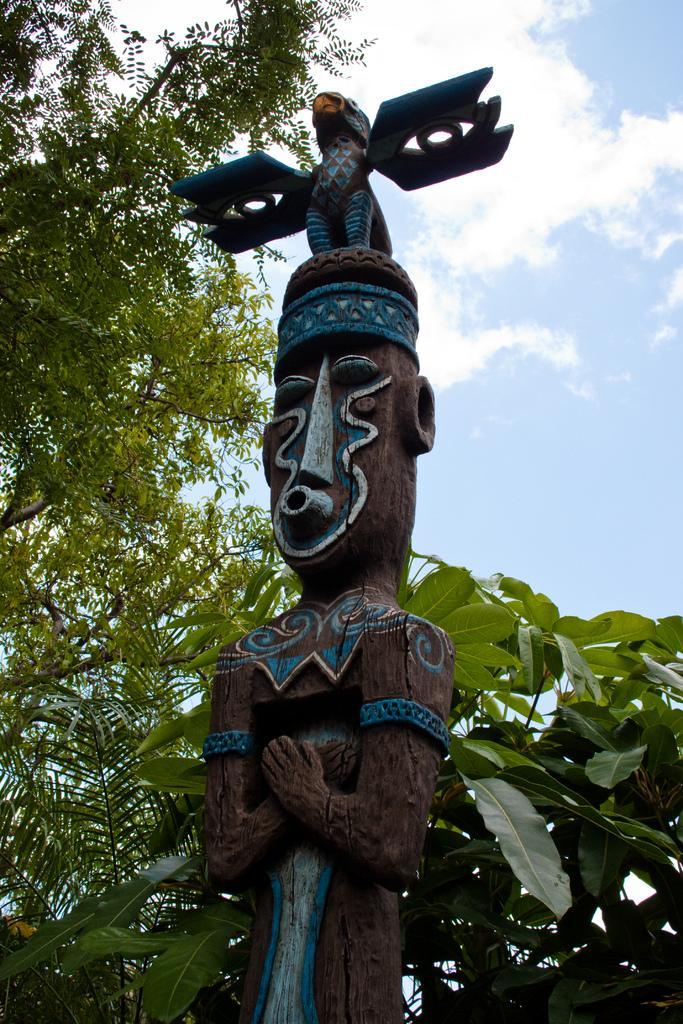How would you summarize this image in a sentence or two? In this image we can see wood carving of a statue. On the backside we can see some trees and the sky which looks cloudy. 